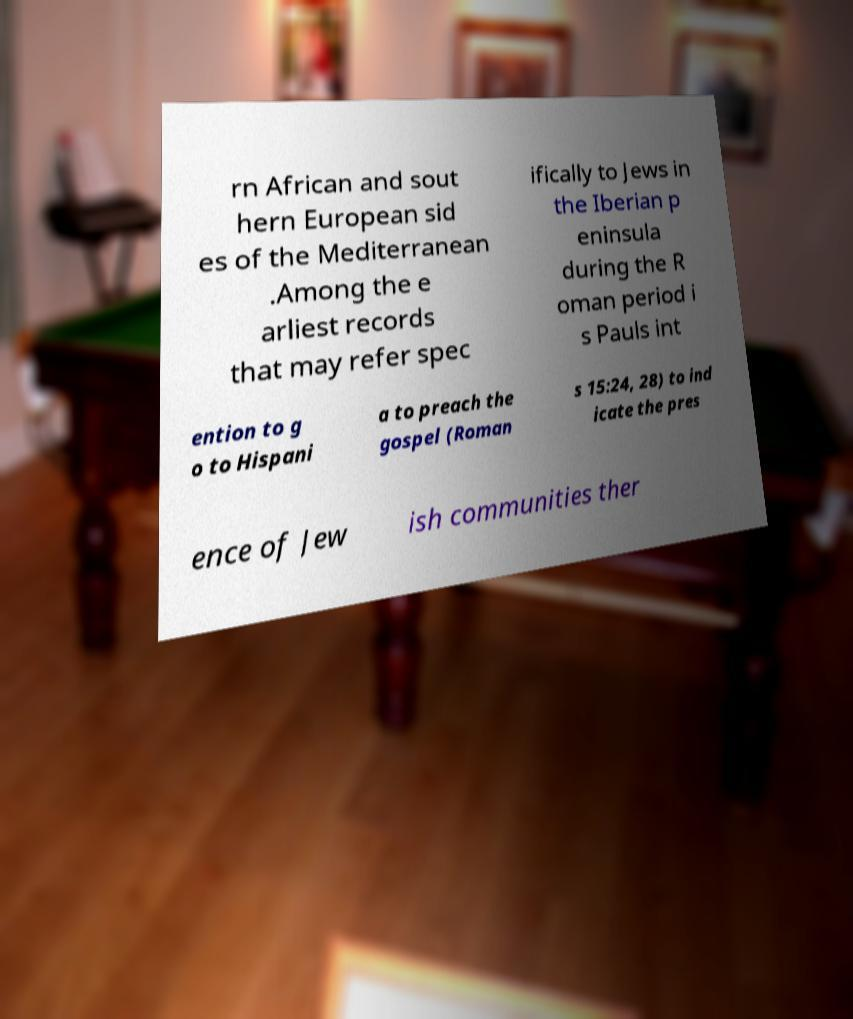Could you extract and type out the text from this image? rn African and sout hern European sid es of the Mediterranean .Among the e arliest records that may refer spec ifically to Jews in the Iberian p eninsula during the R oman period i s Pauls int ention to g o to Hispani a to preach the gospel (Roman s 15:24, 28) to ind icate the pres ence of Jew ish communities ther 